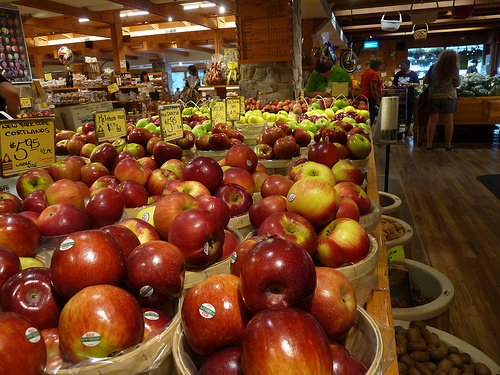<image>
Can you confirm if the apple is on the floor? No. The apple is not positioned on the floor. They may be near each other, but the apple is not supported by or resting on top of the floor. 